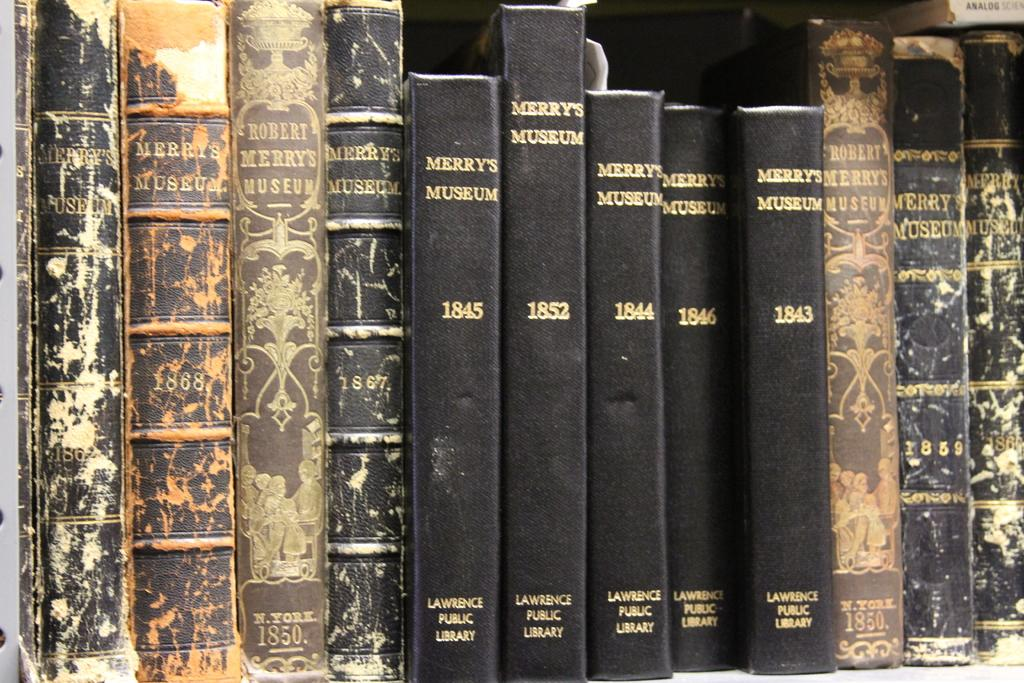<image>
Provide a brief description of the given image. A shelf full of black books that say Merry's Museum. 